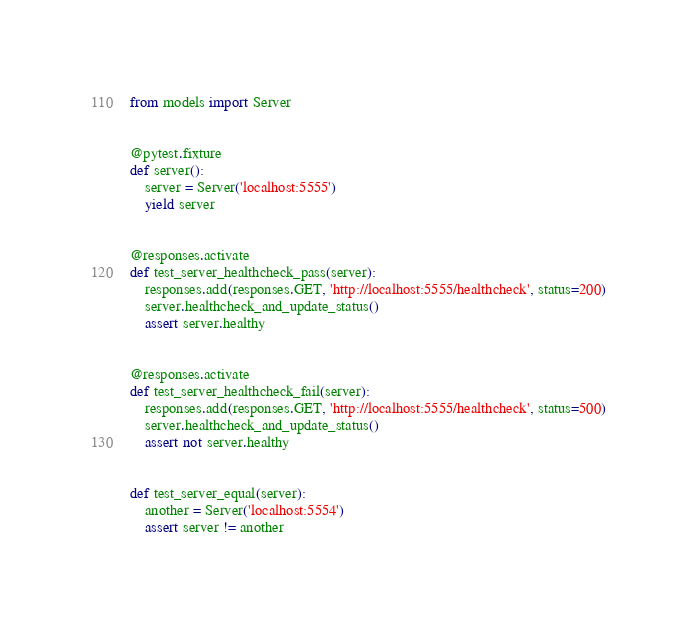<code> <loc_0><loc_0><loc_500><loc_500><_Python_>from models import Server


@pytest.fixture
def server():
    server = Server('localhost:5555')
    yield server


@responses.activate
def test_server_healthcheck_pass(server):
    responses.add(responses.GET, 'http://localhost:5555/healthcheck', status=200)
    server.healthcheck_and_update_status()
    assert server.healthy


@responses.activate
def test_server_healthcheck_fail(server):
    responses.add(responses.GET, 'http://localhost:5555/healthcheck', status=500)
    server.healthcheck_and_update_status()
    assert not server.healthy


def test_server_equal(server):
    another = Server('localhost:5554')
    assert server != another

</code> 